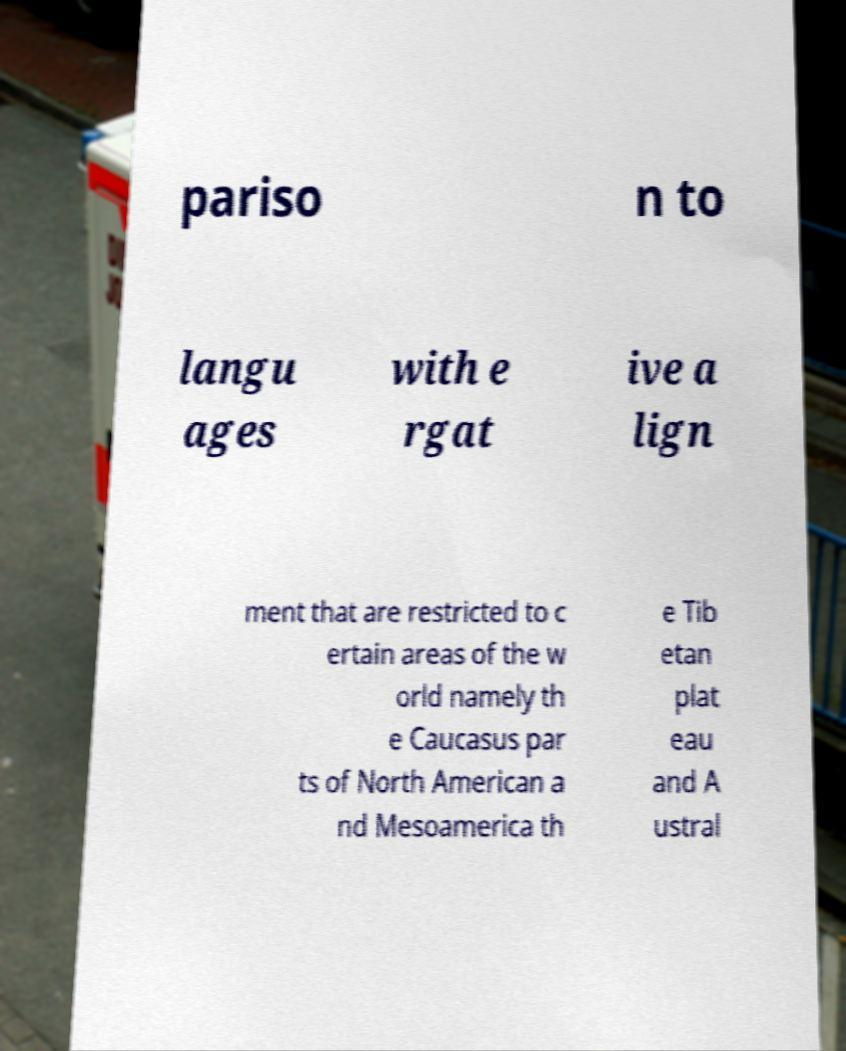Could you extract and type out the text from this image? pariso n to langu ages with e rgat ive a lign ment that are restricted to c ertain areas of the w orld namely th e Caucasus par ts of North American a nd Mesoamerica th e Tib etan plat eau and A ustral 